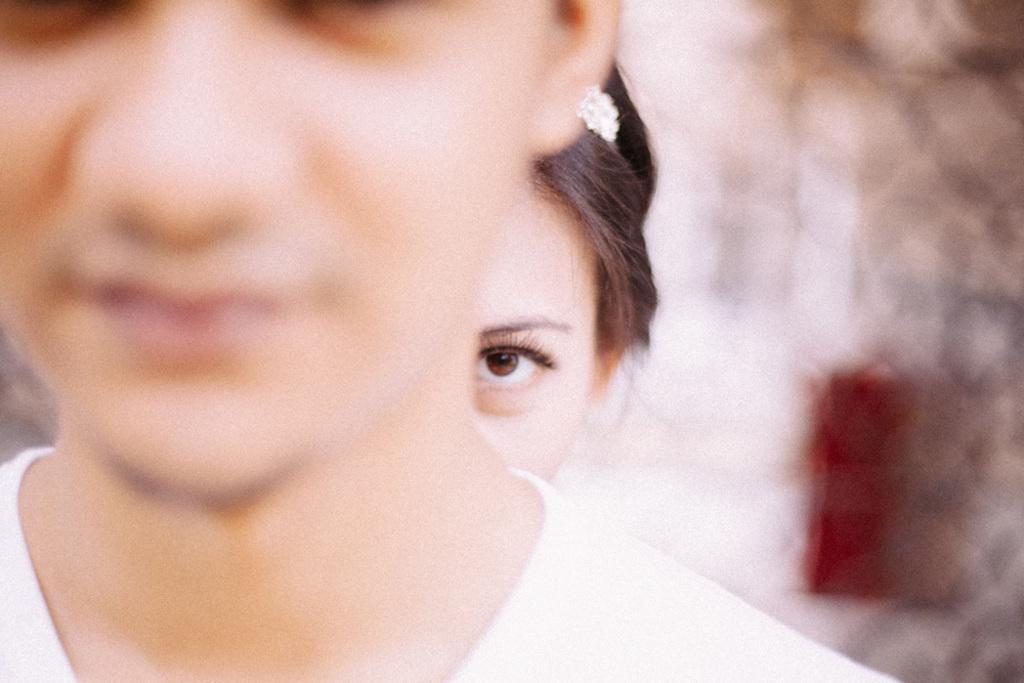How many people are present in the image? There are two women in the image. Can you describe the background of the image? The background of the image is blurred. What type of shock can be seen in the image? There is no shock present in the image; it features two women and a blurred background. What attempt is being made by the women in the image? There is no attempt being made by the women in the image; they are simply present in the scene. 